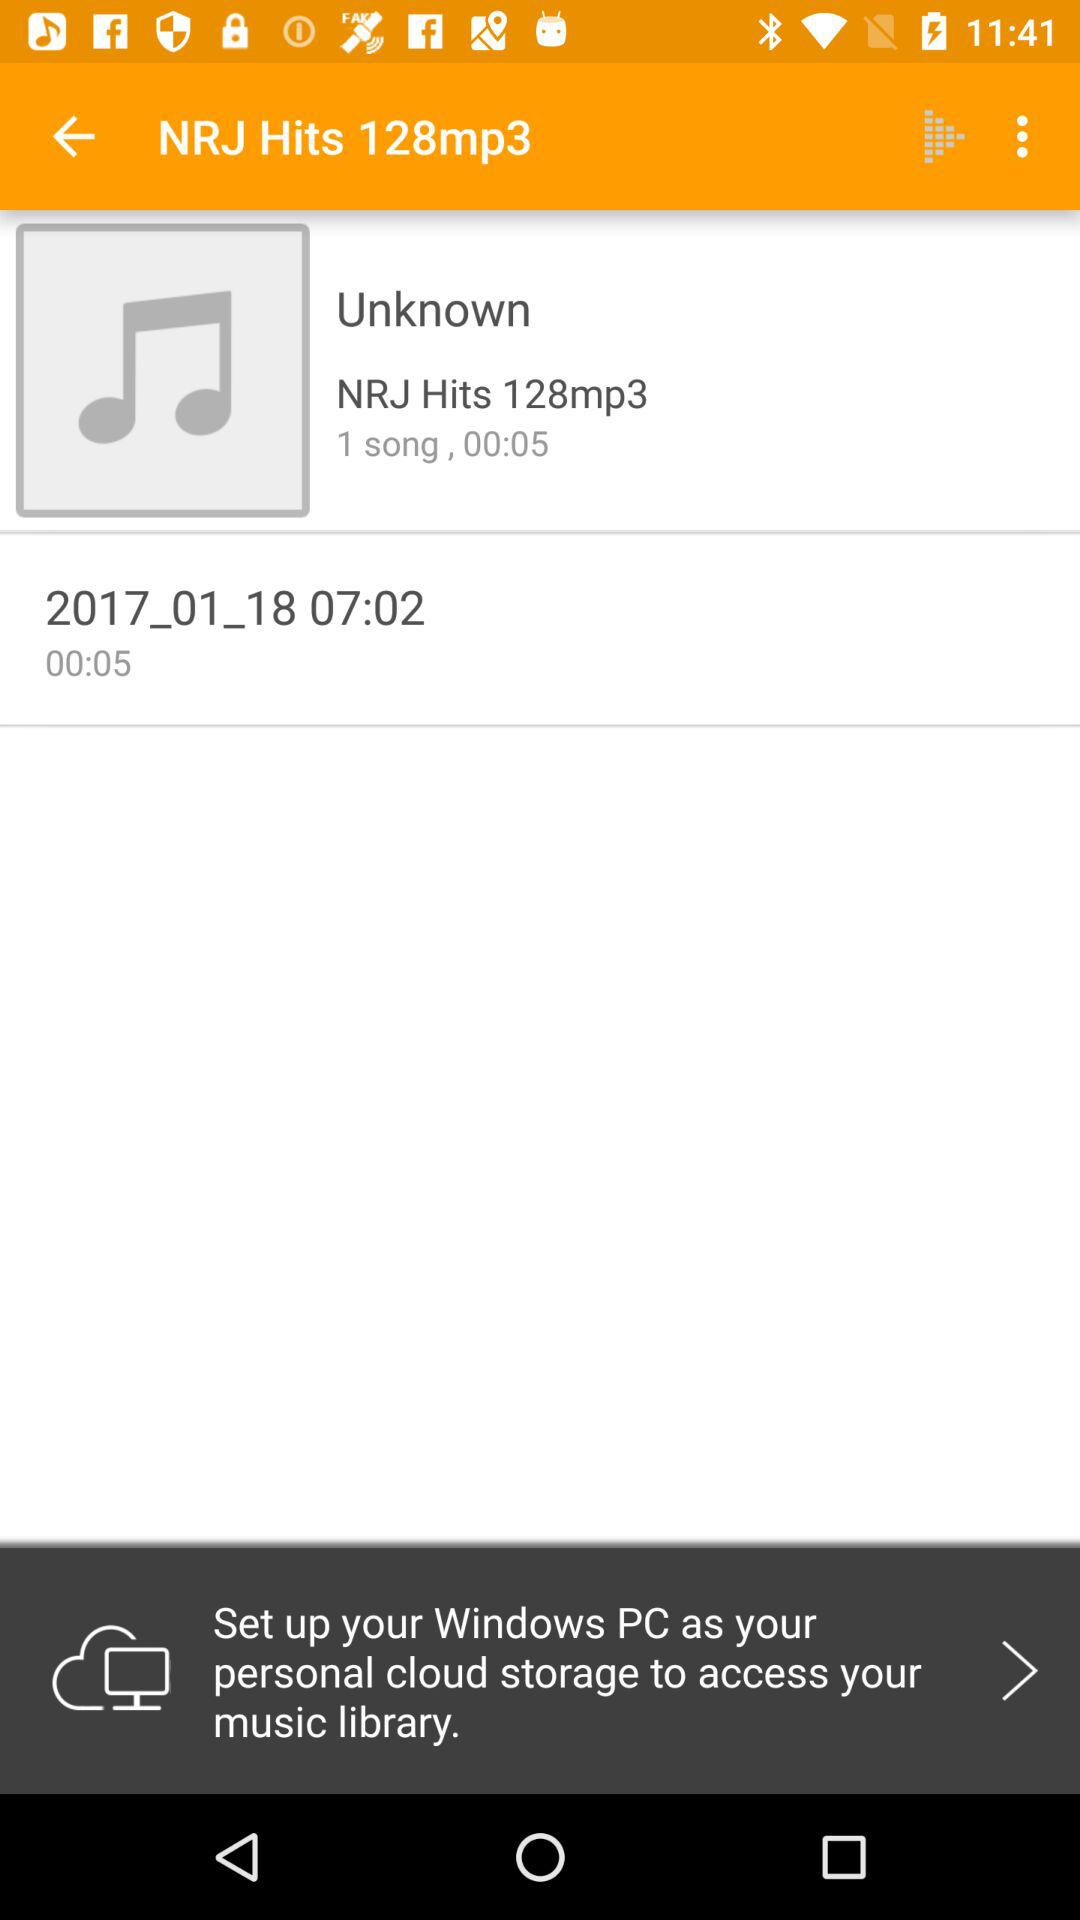How many songs are there? There is 1 song. 